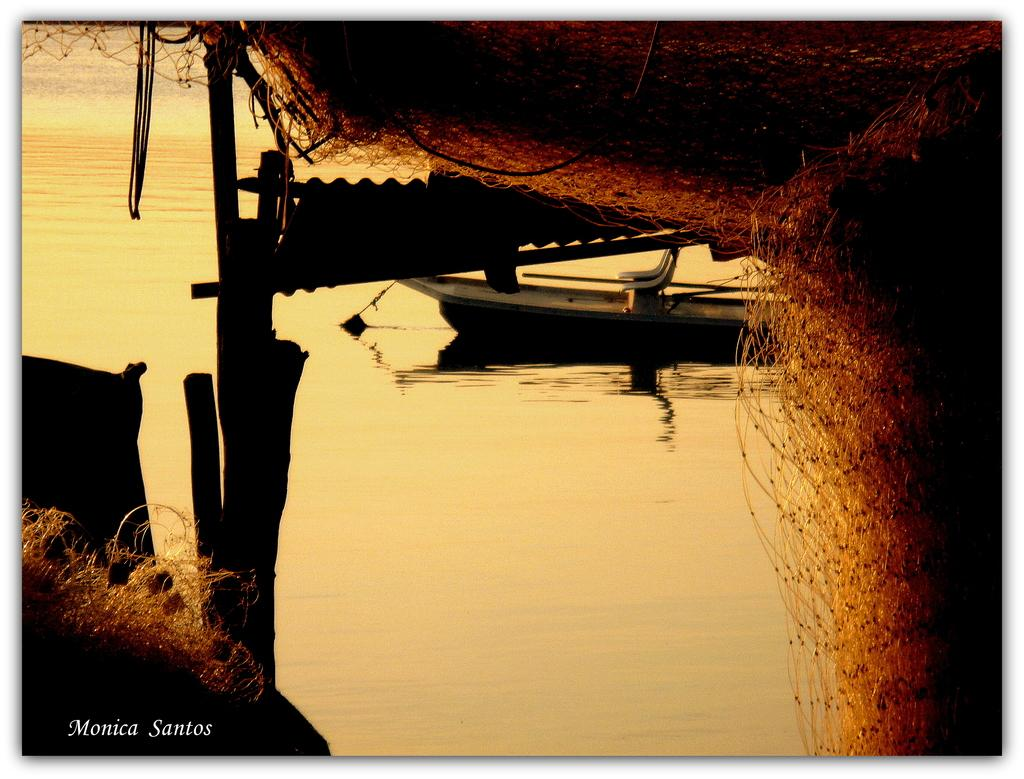What is the main subject of the image? The main subject of the image is a boat. Where is the boat located? The boat is on the water. What is the boat carrying or using in the image? There is a fishing net in the image. Is there any additional information about the image itself? Yes, there is a watermark on the image. What type of music is playing in the background of the image? There is no music playing in the background of the image; it is a still image of a boat on the water. 